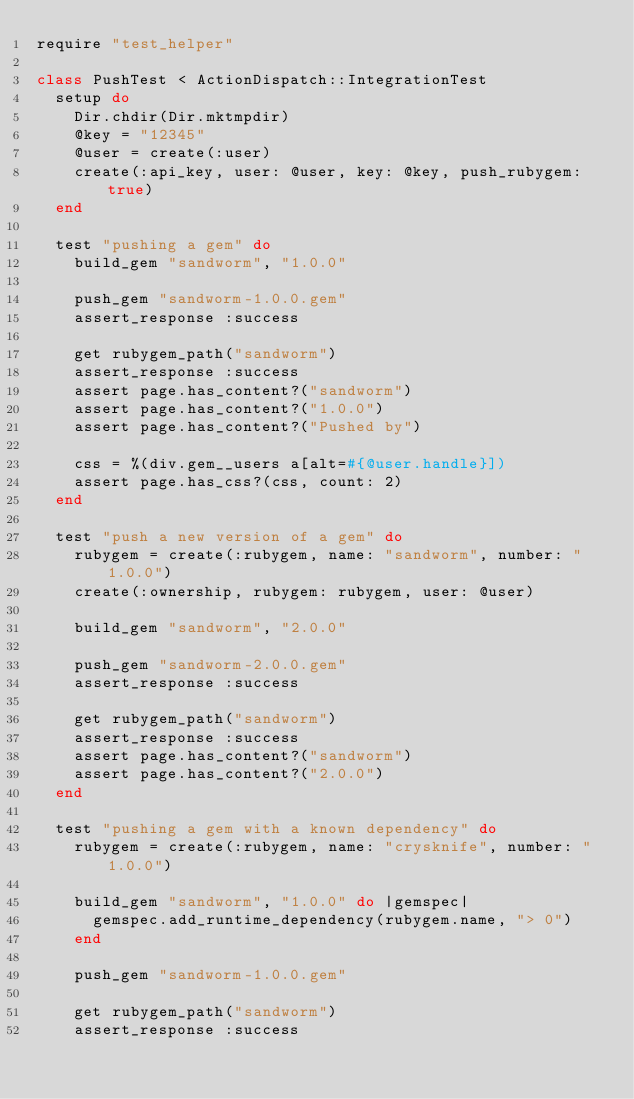<code> <loc_0><loc_0><loc_500><loc_500><_Ruby_>require "test_helper"

class PushTest < ActionDispatch::IntegrationTest
  setup do
    Dir.chdir(Dir.mktmpdir)
    @key = "12345"
    @user = create(:user)
    create(:api_key, user: @user, key: @key, push_rubygem: true)
  end

  test "pushing a gem" do
    build_gem "sandworm", "1.0.0"

    push_gem "sandworm-1.0.0.gem"
    assert_response :success

    get rubygem_path("sandworm")
    assert_response :success
    assert page.has_content?("sandworm")
    assert page.has_content?("1.0.0")
    assert page.has_content?("Pushed by")

    css = %(div.gem__users a[alt=#{@user.handle}])
    assert page.has_css?(css, count: 2)
  end

  test "push a new version of a gem" do
    rubygem = create(:rubygem, name: "sandworm", number: "1.0.0")
    create(:ownership, rubygem: rubygem, user: @user)

    build_gem "sandworm", "2.0.0"

    push_gem "sandworm-2.0.0.gem"
    assert_response :success

    get rubygem_path("sandworm")
    assert_response :success
    assert page.has_content?("sandworm")
    assert page.has_content?("2.0.0")
  end

  test "pushing a gem with a known dependency" do
    rubygem = create(:rubygem, name: "crysknife", number: "1.0.0")

    build_gem "sandworm", "1.0.0" do |gemspec|
      gemspec.add_runtime_dependency(rubygem.name, "> 0")
    end

    push_gem "sandworm-1.0.0.gem"

    get rubygem_path("sandworm")
    assert_response :success</code> 